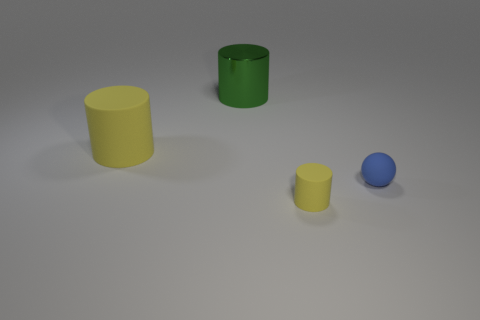Add 4 green cylinders. How many objects exist? 8 Subtract all tiny rubber cylinders. How many cylinders are left? 2 Subtract all green cylinders. How many cylinders are left? 2 Subtract all green balls. How many yellow cylinders are left? 2 Subtract 1 spheres. How many spheres are left? 0 Subtract 0 brown cubes. How many objects are left? 4 Subtract all cylinders. How many objects are left? 1 Subtract all red cylinders. Subtract all green balls. How many cylinders are left? 3 Subtract all large things. Subtract all big green shiny objects. How many objects are left? 1 Add 4 metal cylinders. How many metal cylinders are left? 5 